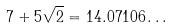Convert formula to latex. <formula><loc_0><loc_0><loc_500><loc_500>7 + 5 \sqrt { 2 } = 1 4 . 0 7 1 0 6 \dots</formula> 